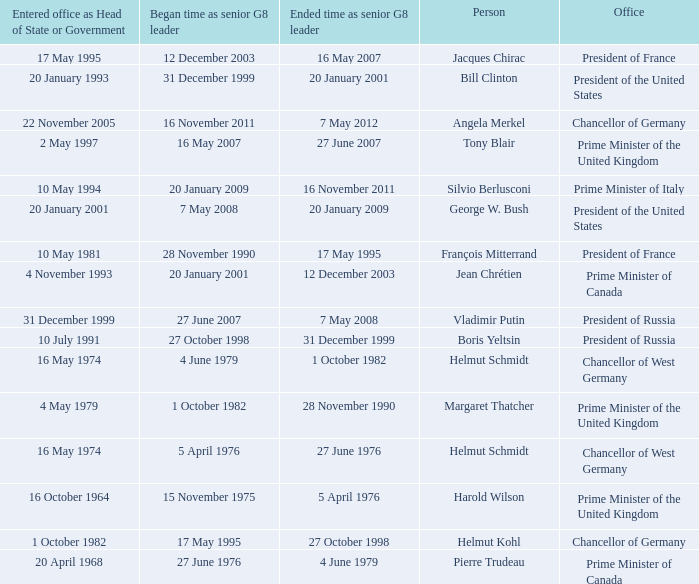When did the Prime Minister of Italy take office? 10 May 1994. 